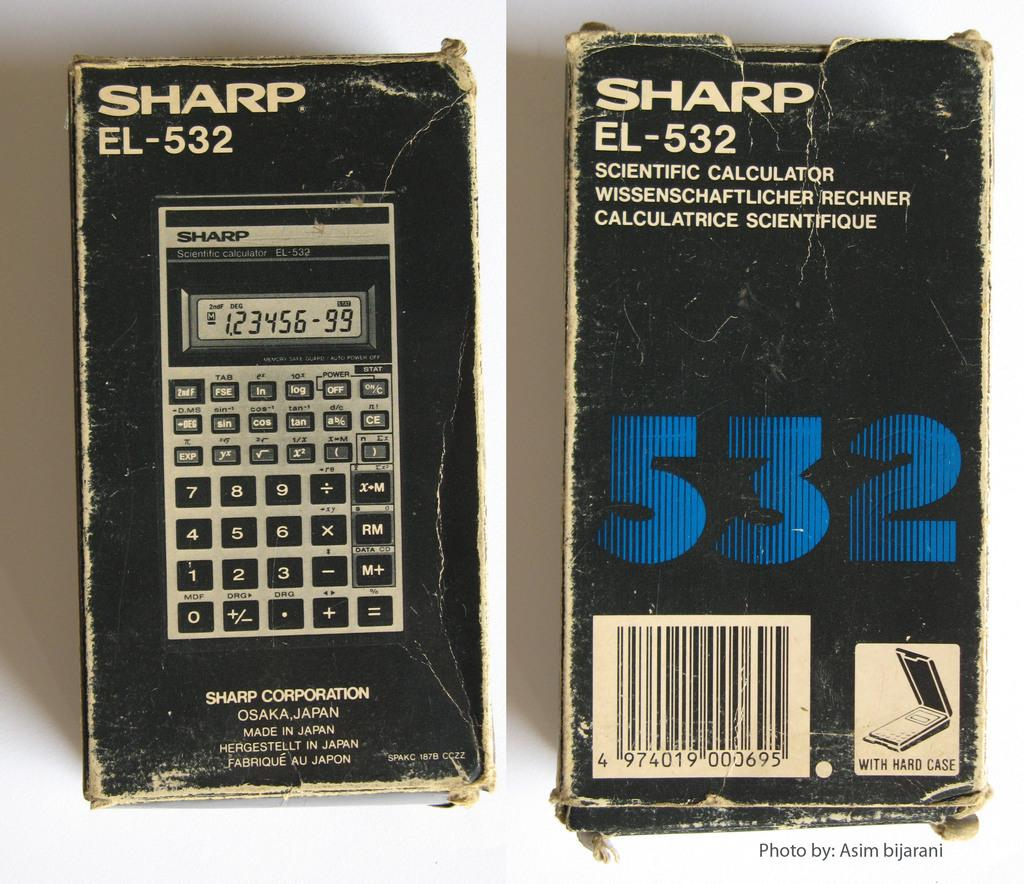<image>
Share a concise interpretation of the image provided. Sharp EL-532 is the model number shown on this calculator box. 